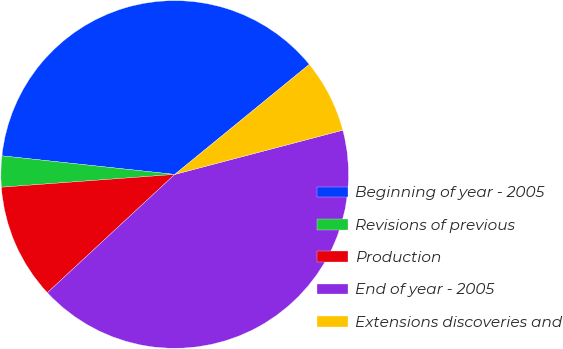<chart> <loc_0><loc_0><loc_500><loc_500><pie_chart><fcel>Beginning of year - 2005<fcel>Revisions of previous<fcel>Production<fcel>End of year - 2005<fcel>Extensions discoveries and<nl><fcel>37.39%<fcel>2.88%<fcel>10.74%<fcel>42.19%<fcel>6.81%<nl></chart> 